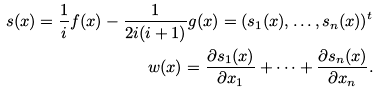<formula> <loc_0><loc_0><loc_500><loc_500>s ( x ) = \frac { 1 } { i } f ( x ) - \frac { 1 } { 2 i ( i + 1 ) } g ( x ) = ( s _ { 1 } ( x ) , \dots , s _ { n } ( x ) ) ^ { t } \\ w ( x ) = \frac { \partial s _ { 1 } ( x ) } { \partial x _ { 1 } } + \cdots + \frac { \partial s _ { n } ( x ) } { \partial x _ { n } } .</formula> 